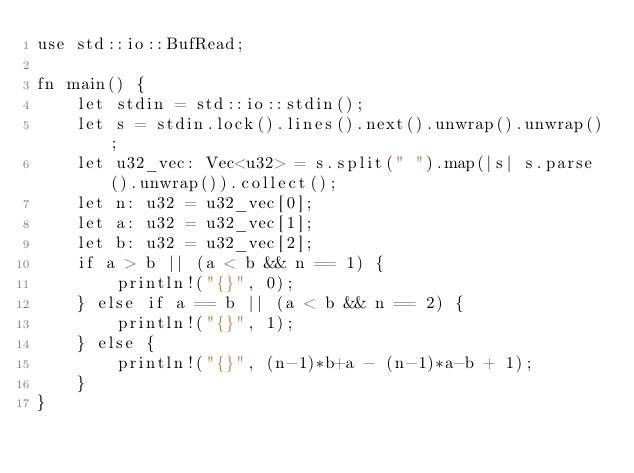<code> <loc_0><loc_0><loc_500><loc_500><_Rust_>use std::io::BufRead;

fn main() {
    let stdin = std::io::stdin();
    let s = stdin.lock().lines().next().unwrap().unwrap();
    let u32_vec: Vec<u32> = s.split(" ").map(|s| s.parse().unwrap()).collect();
    let n: u32 = u32_vec[0];
    let a: u32 = u32_vec[1];
    let b: u32 = u32_vec[2];
    if a > b || (a < b && n == 1) {
        println!("{}", 0);
    } else if a == b || (a < b && n == 2) {
        println!("{}", 1);
    } else {
        println!("{}", (n-1)*b+a - (n-1)*a-b + 1);
    }
}
</code> 